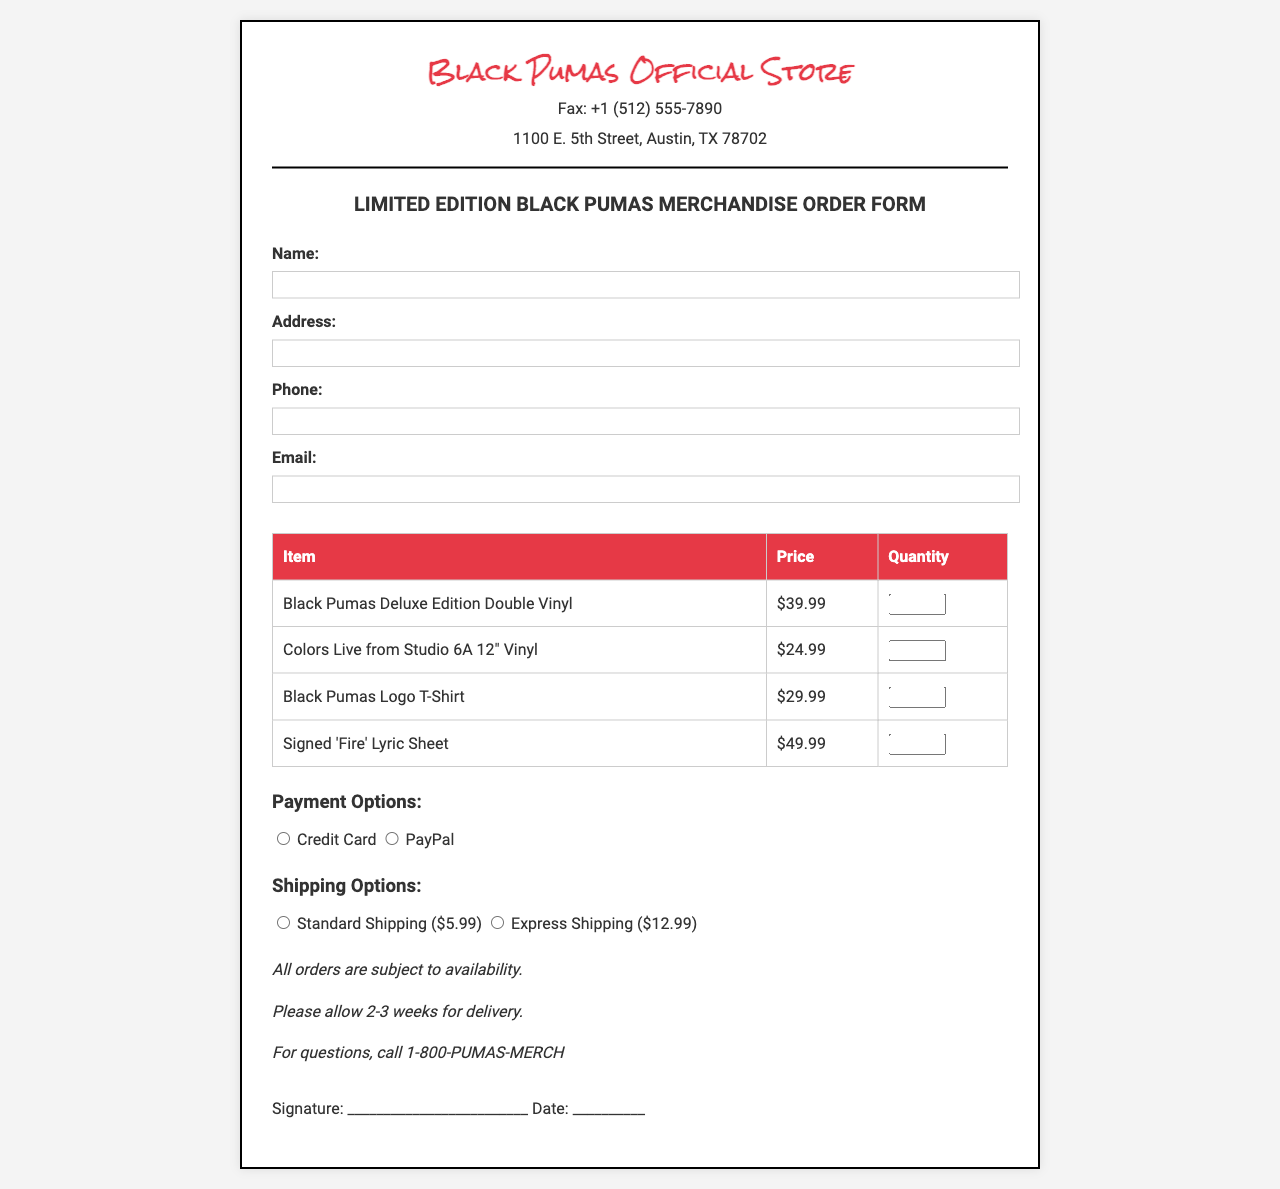What is the fax number? The fax number is listed in the contact information section of the document.
Answer: +1 (512) 555-7890 How many types of vinyl records are offered on the order form? The document provides a listing of vinyl records, which includes two types.
Answer: 2 What is the price of the Black Pumas Logo T-Shirt? The price is displayed in the merchandise table among other items.
Answer: $29.99 What shipping option is available for $12.99? The shipping options are listed with corresponding prices.
Answer: Express Shipping What is the total time to expect for delivery? The document specifies a delivery timeframe based on the order processing information.
Answer: 2-3 weeks 